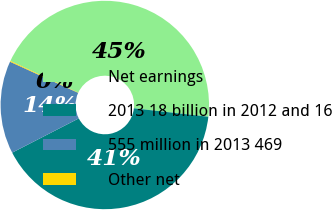Convert chart. <chart><loc_0><loc_0><loc_500><loc_500><pie_chart><fcel>Net earnings<fcel>2013 18 billion in 2012 and 16<fcel>555 million in 2013 469<fcel>Other net<nl><fcel>44.85%<fcel>40.64%<fcel>14.38%<fcel>0.13%<nl></chart> 